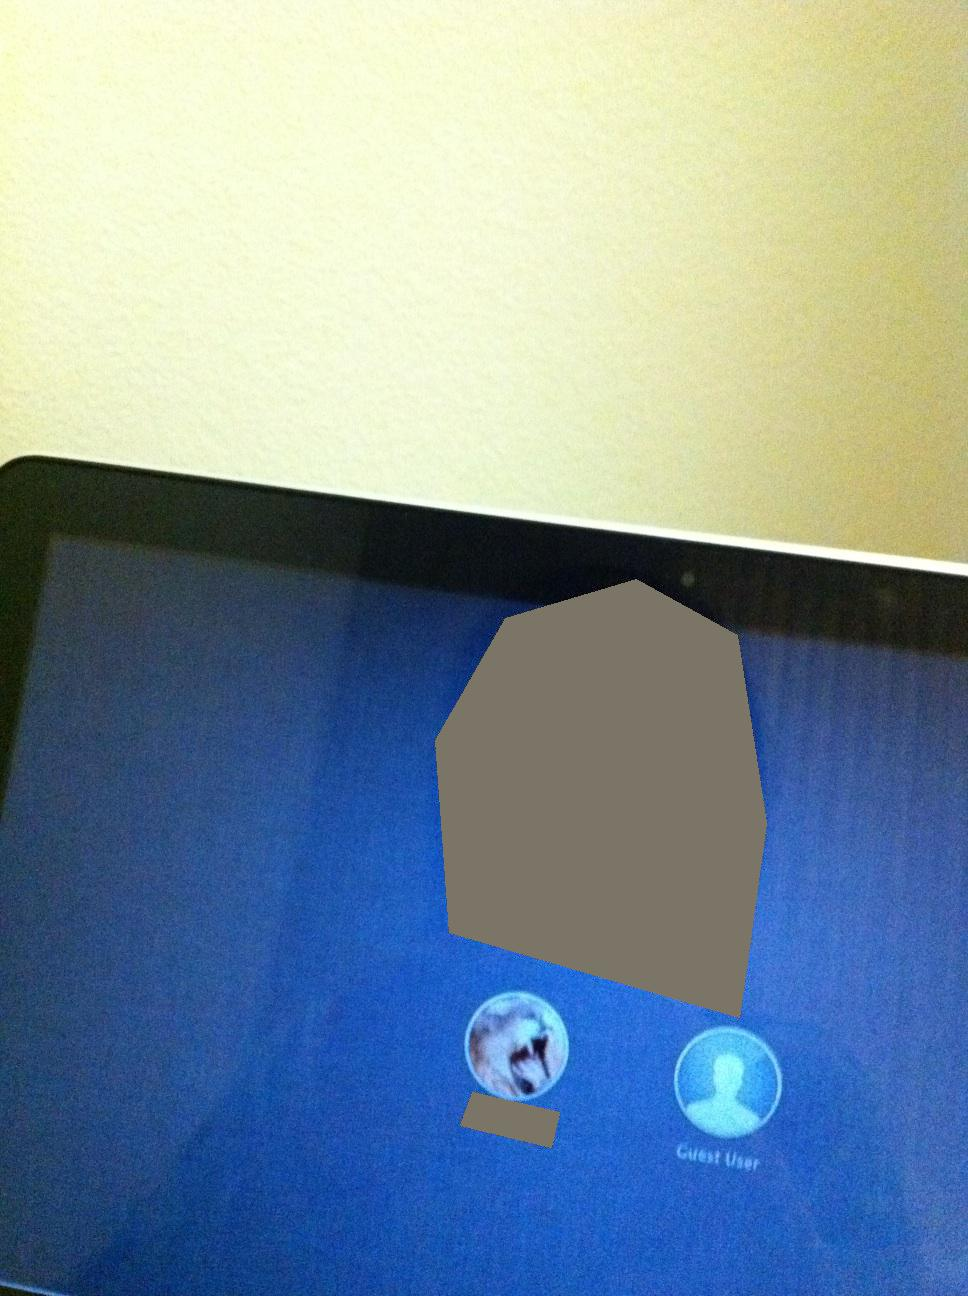Can you describe the two user options displayed on the screen? The login screen displays two user options. The first option features an avatar, possibly representing a regular user account. The second option is labeled 'Guest User' and displays a generic user icon. 